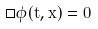Convert formula to latex. <formula><loc_0><loc_0><loc_500><loc_500>\Box \phi ( t , x ) = 0</formula> 